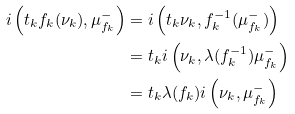<formula> <loc_0><loc_0><loc_500><loc_500>i \left ( t _ { k } f _ { k } ( \nu _ { k } ) , \mu ^ { - } _ { f _ { k } } \right ) & = i \left ( t _ { k } \nu _ { k } , f _ { k } ^ { - 1 } ( \mu ^ { - } _ { f _ { k } } ) \right ) \\ & = t _ { k } i \left ( \nu _ { k } , \lambda ( f _ { k } ^ { - 1 } ) \mu ^ { - } _ { f _ { k } } \right ) \\ & = t _ { k } \lambda ( f _ { k } ) i \left ( \nu _ { k } , \mu ^ { - } _ { f _ { k } } \right )</formula> 